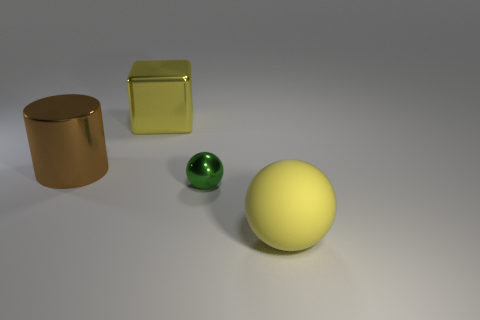Add 1 small red matte cylinders. How many objects exist? 5 Subtract all cylinders. How many objects are left? 3 Add 2 big yellow metal objects. How many big yellow metal objects are left? 3 Add 1 large spheres. How many large spheres exist? 2 Subtract 0 blue cylinders. How many objects are left? 4 Subtract all big cylinders. Subtract all small green metallic balls. How many objects are left? 2 